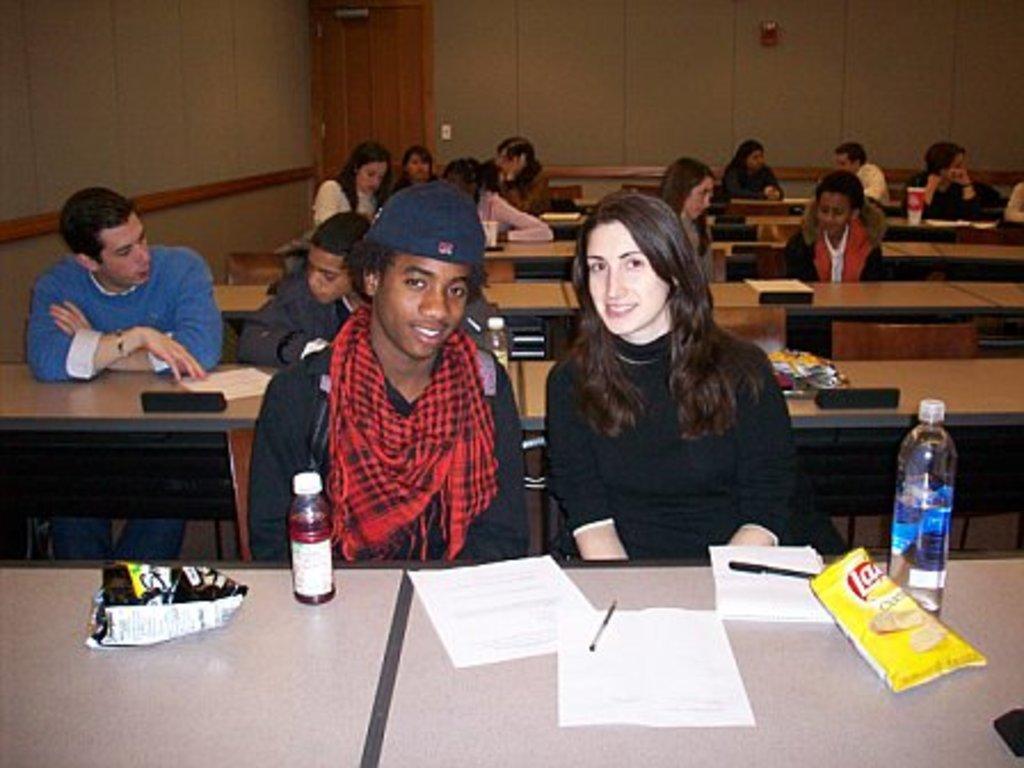How would you summarize this image in a sentence or two? In this picture there is a man who is sitting on the chair and there is a woman who is sitting on the chair. There is a bottle on the table. There is a paper and pen on the table. There is also chips packet on the table. At the background there are group of people on the chair. There is a door. 